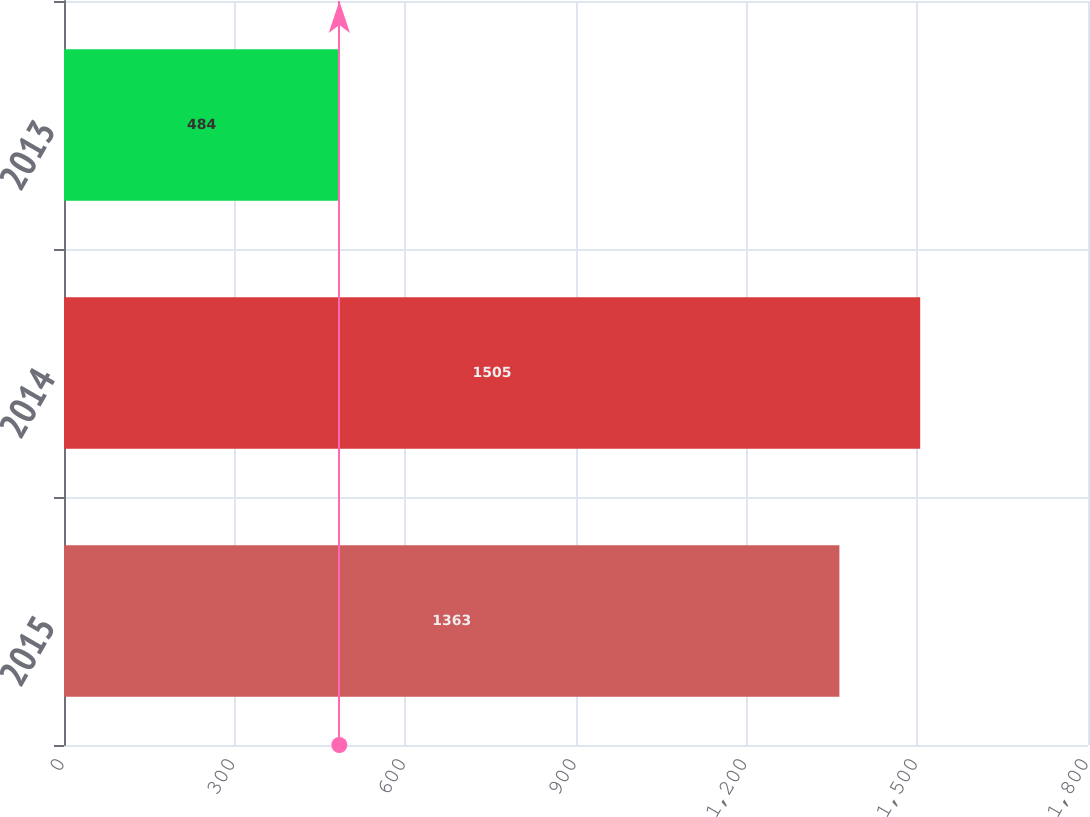Convert chart. <chart><loc_0><loc_0><loc_500><loc_500><bar_chart><fcel>2015<fcel>2014<fcel>2013<nl><fcel>1363<fcel>1505<fcel>484<nl></chart> 